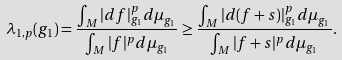<formula> <loc_0><loc_0><loc_500><loc_500>\lambda _ { 1 , p } ( g _ { 1 } ) = \frac { \int _ { M } | d f | _ { g _ { 1 } } ^ { p } d \mu _ { g _ { 1 } } } { \int _ { M } | f | ^ { p } d \mu _ { g _ { 1 } } } \geq \frac { \int _ { M } | d ( f + s ) | _ { g _ { 1 } } ^ { p } d \mu _ { g _ { 1 } } } { \int _ { M } | f + s | ^ { p } d \mu _ { g _ { 1 } } } .</formula> 